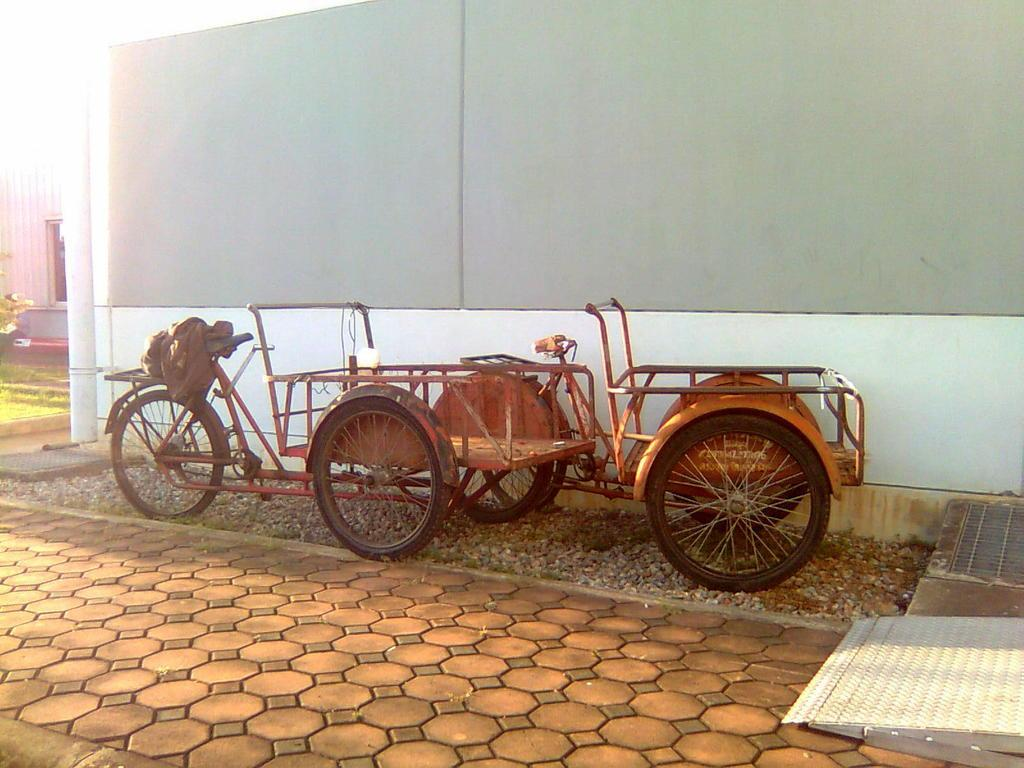How many vehicles can be seen in the image? There are two vehicles in the image. What else is visible in the image besides the vehicles? There is a wall visible in the image. What type of cast can be seen on the vehicles in the image? There is no cast present on the vehicles in the image. What sound can be heard coming from the vehicles in the image? There is no sound present in the image, as it is a still image. 